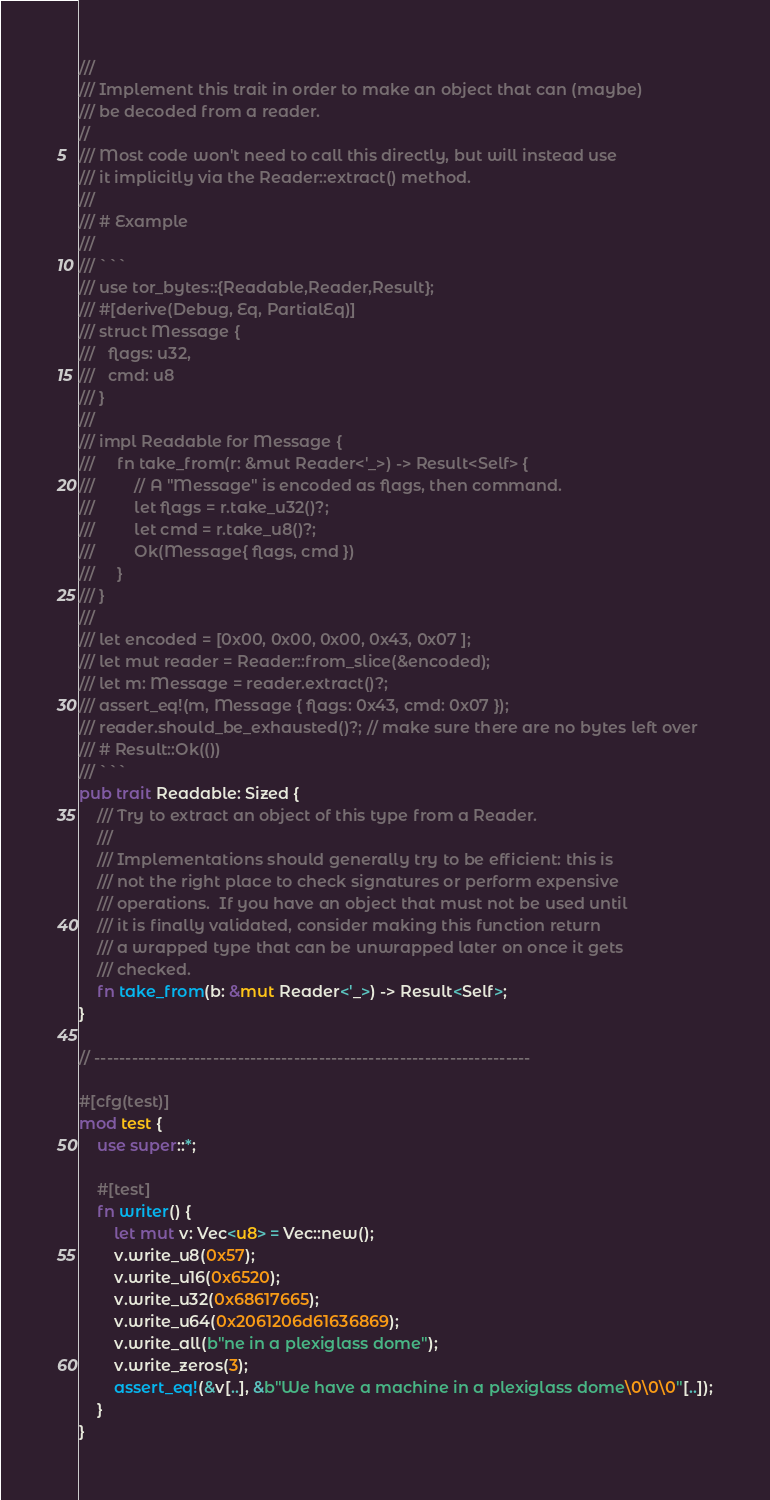<code> <loc_0><loc_0><loc_500><loc_500><_Rust_>///
/// Implement this trait in order to make an object that can (maybe)
/// be decoded from a reader.
//
/// Most code won't need to call this directly, but will instead use
/// it implicitly via the Reader::extract() method.
///
/// # Example
///
/// ```
/// use tor_bytes::{Readable,Reader,Result};
/// #[derive(Debug, Eq, PartialEq)]
/// struct Message {
///   flags: u32,
///   cmd: u8
/// }
///
/// impl Readable for Message {
///     fn take_from(r: &mut Reader<'_>) -> Result<Self> {
///         // A "Message" is encoded as flags, then command.
///         let flags = r.take_u32()?;
///         let cmd = r.take_u8()?;
///         Ok(Message{ flags, cmd })
///     }
/// }
///
/// let encoded = [0x00, 0x00, 0x00, 0x43, 0x07 ];
/// let mut reader = Reader::from_slice(&encoded);
/// let m: Message = reader.extract()?;
/// assert_eq!(m, Message { flags: 0x43, cmd: 0x07 });
/// reader.should_be_exhausted()?; // make sure there are no bytes left over
/// # Result::Ok(())
/// ```
pub trait Readable: Sized {
    /// Try to extract an object of this type from a Reader.
    ///
    /// Implementations should generally try to be efficient: this is
    /// not the right place to check signatures or perform expensive
    /// operations.  If you have an object that must not be used until
    /// it is finally validated, consider making this function return
    /// a wrapped type that can be unwrapped later on once it gets
    /// checked.
    fn take_from(b: &mut Reader<'_>) -> Result<Self>;
}

// ----------------------------------------------------------------------

#[cfg(test)]
mod test {
    use super::*;

    #[test]
    fn writer() {
        let mut v: Vec<u8> = Vec::new();
        v.write_u8(0x57);
        v.write_u16(0x6520);
        v.write_u32(0x68617665);
        v.write_u64(0x2061206d61636869);
        v.write_all(b"ne in a plexiglass dome");
        v.write_zeros(3);
        assert_eq!(&v[..], &b"We have a machine in a plexiglass dome\0\0\0"[..]);
    }
}
</code> 